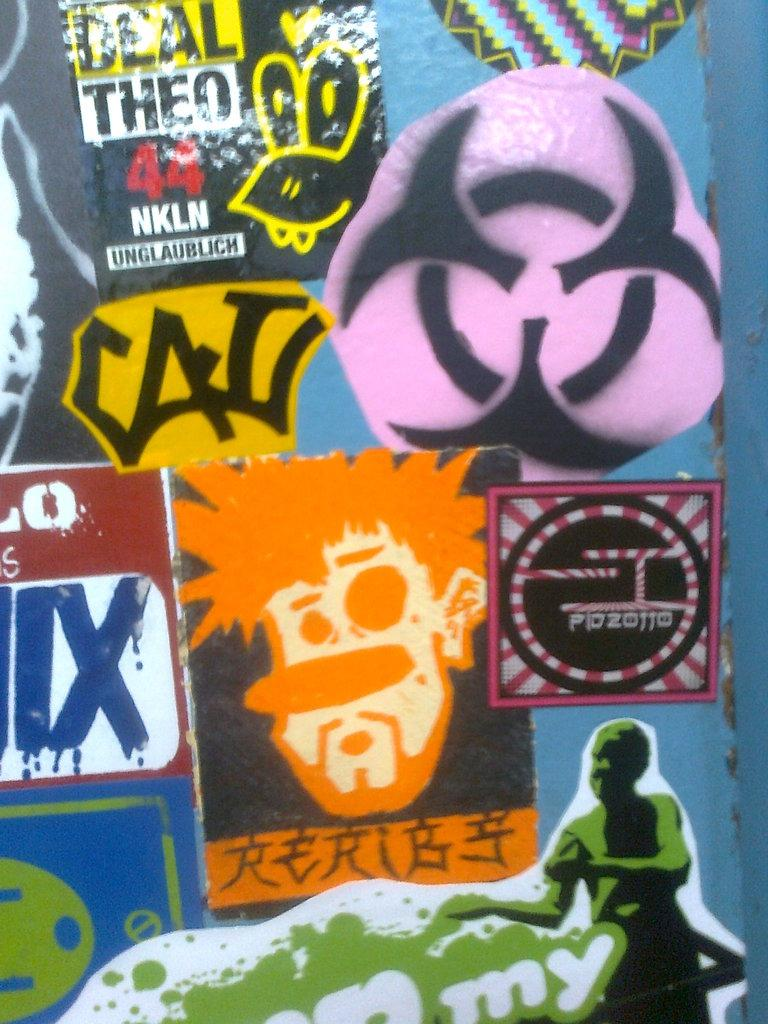<image>
Share a concise interpretation of the image provided. Stickers cover the display like one with a red number 44. 